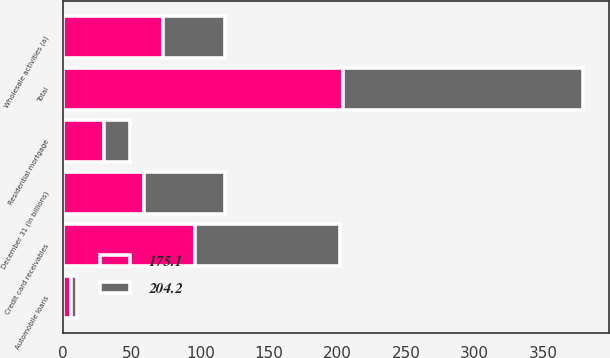<chart> <loc_0><loc_0><loc_500><loc_500><stacked_bar_chart><ecel><fcel>December 31 (in billions)<fcel>Credit card receivables<fcel>Residential mortgage<fcel>Wholesale activities (a)<fcel>Automobile loans<fcel>Total<nl><fcel>175.1<fcel>58.85<fcel>96<fcel>29.8<fcel>72.9<fcel>5.5<fcel>204.2<nl><fcel>204.2<fcel>58.85<fcel>106.3<fcel>19.1<fcel>44.8<fcel>4.9<fcel>175.1<nl></chart> 